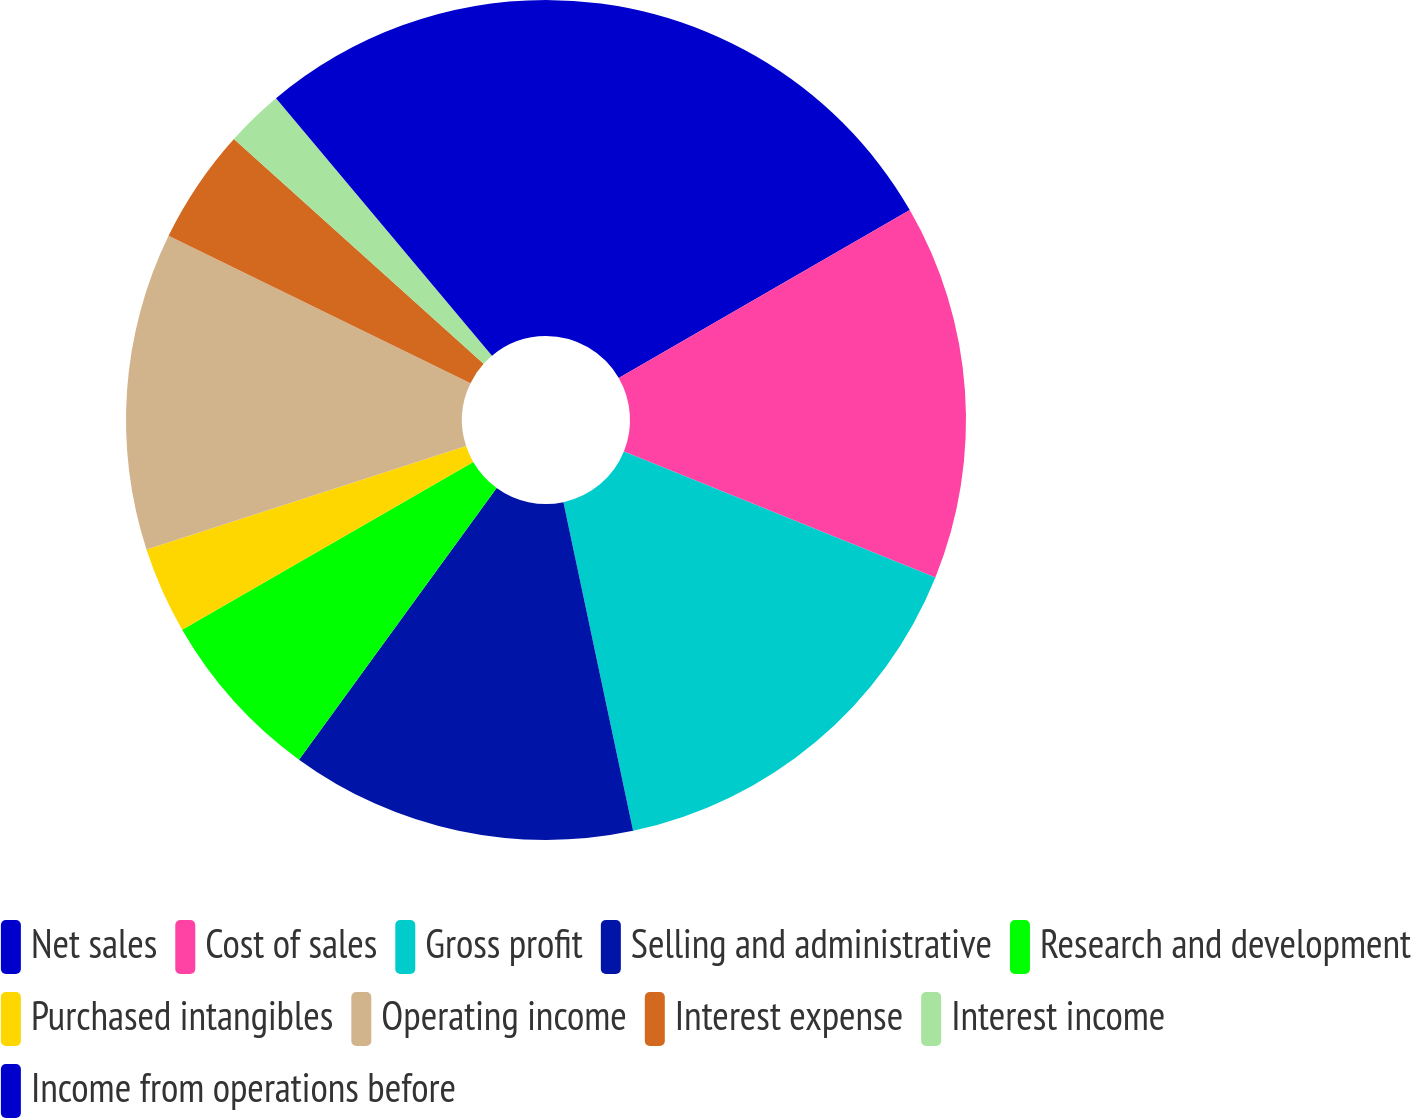<chart> <loc_0><loc_0><loc_500><loc_500><pie_chart><fcel>Net sales<fcel>Cost of sales<fcel>Gross profit<fcel>Selling and administrative<fcel>Research and development<fcel>Purchased intangibles<fcel>Operating income<fcel>Interest expense<fcel>Interest income<fcel>Income from operations before<nl><fcel>16.67%<fcel>14.44%<fcel>15.56%<fcel>13.33%<fcel>6.67%<fcel>3.33%<fcel>12.22%<fcel>4.44%<fcel>2.22%<fcel>11.11%<nl></chart> 